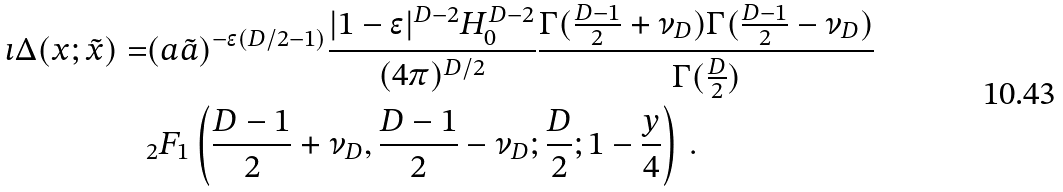<formula> <loc_0><loc_0><loc_500><loc_500>\imath \Delta ( x ; \tilde { x } ) = & ( a \tilde { a } ) ^ { - \epsilon ( D / 2 - 1 ) } \frac { | 1 - \epsilon | ^ { D - 2 } H _ { 0 } ^ { D - 2 } } { ( 4 \pi ) ^ { D / 2 } } \frac { \Gamma ( \frac { D - 1 } { 2 } + \nu _ { D } ) \Gamma ( \frac { D - 1 } { 2 } - \nu _ { D } ) } { \Gamma ( \frac { D } { 2 } ) } \\ & _ { 2 } F _ { 1 } \left ( \frac { D - 1 } { 2 } + \nu _ { D } , \frac { D - 1 } { 2 } - \nu _ { D } ; \frac { D } { 2 } ; 1 - \frac { y } { 4 } \right ) \, .</formula> 